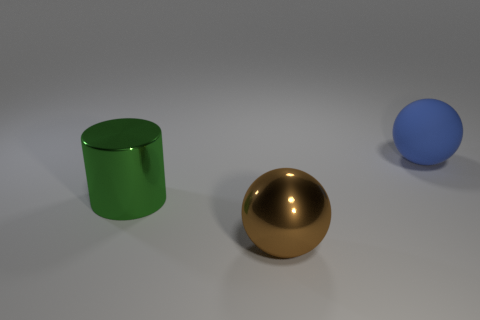There is a thing on the right side of the large ball that is left of the big blue matte sphere; are there any large things that are in front of it? Based on the image provided, the green cylindrical object is to the right of the large golden ball, which in turn is left of the blue matte sphere. There are no large objects directly in front of the green cylinder. 